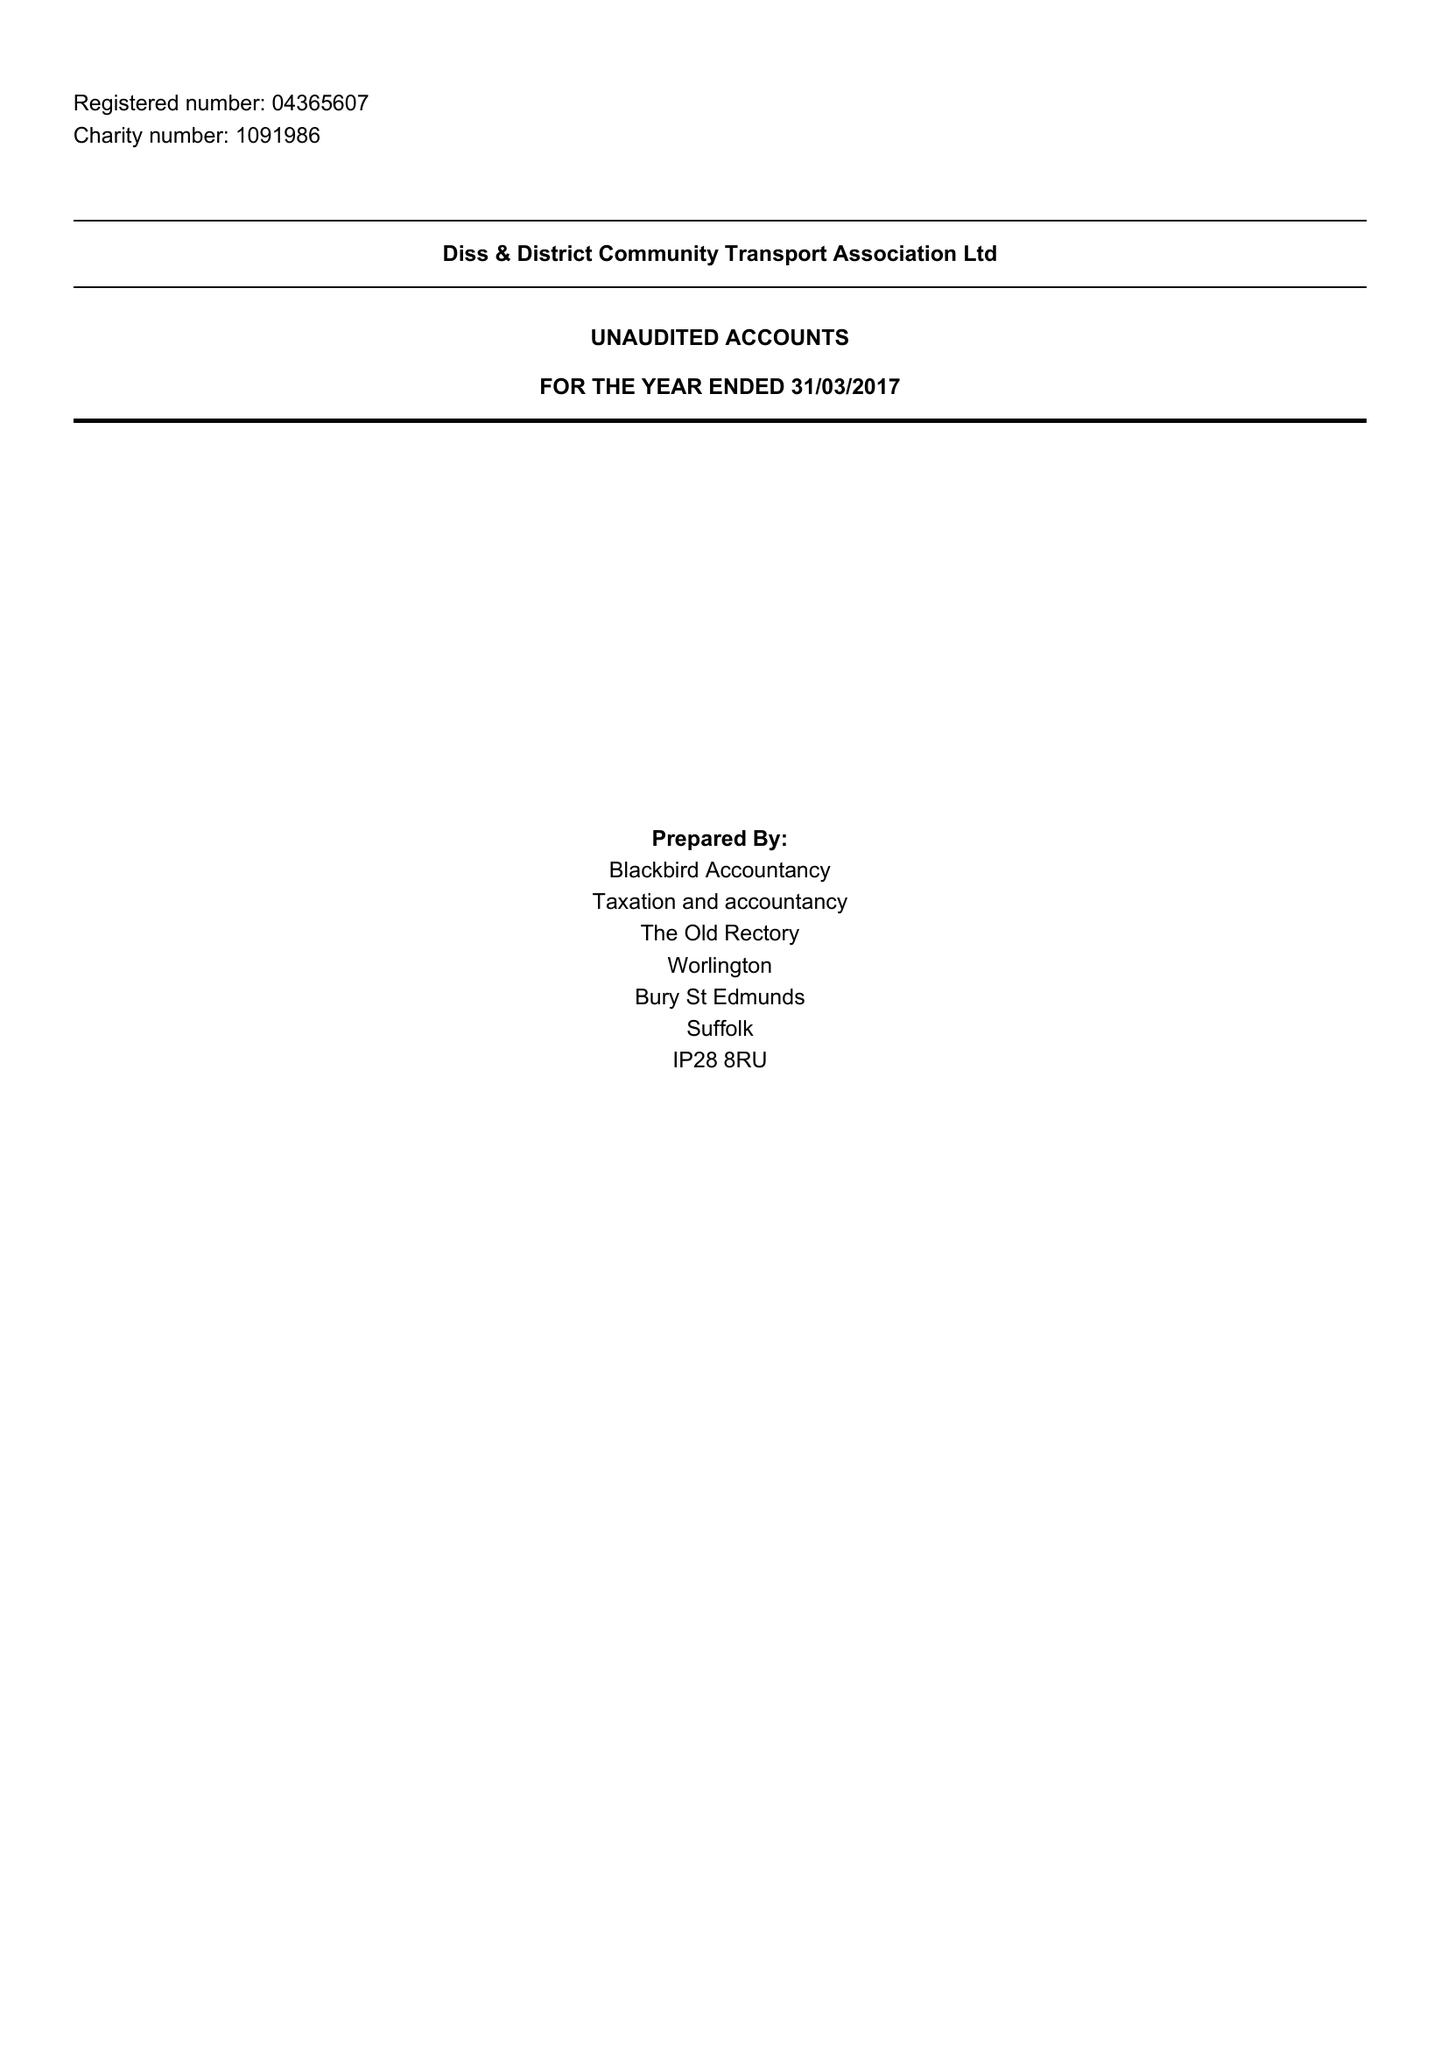What is the value for the charity_name?
Answer the question using a single word or phrase. Diss and District Community Transport Association Ltd. 